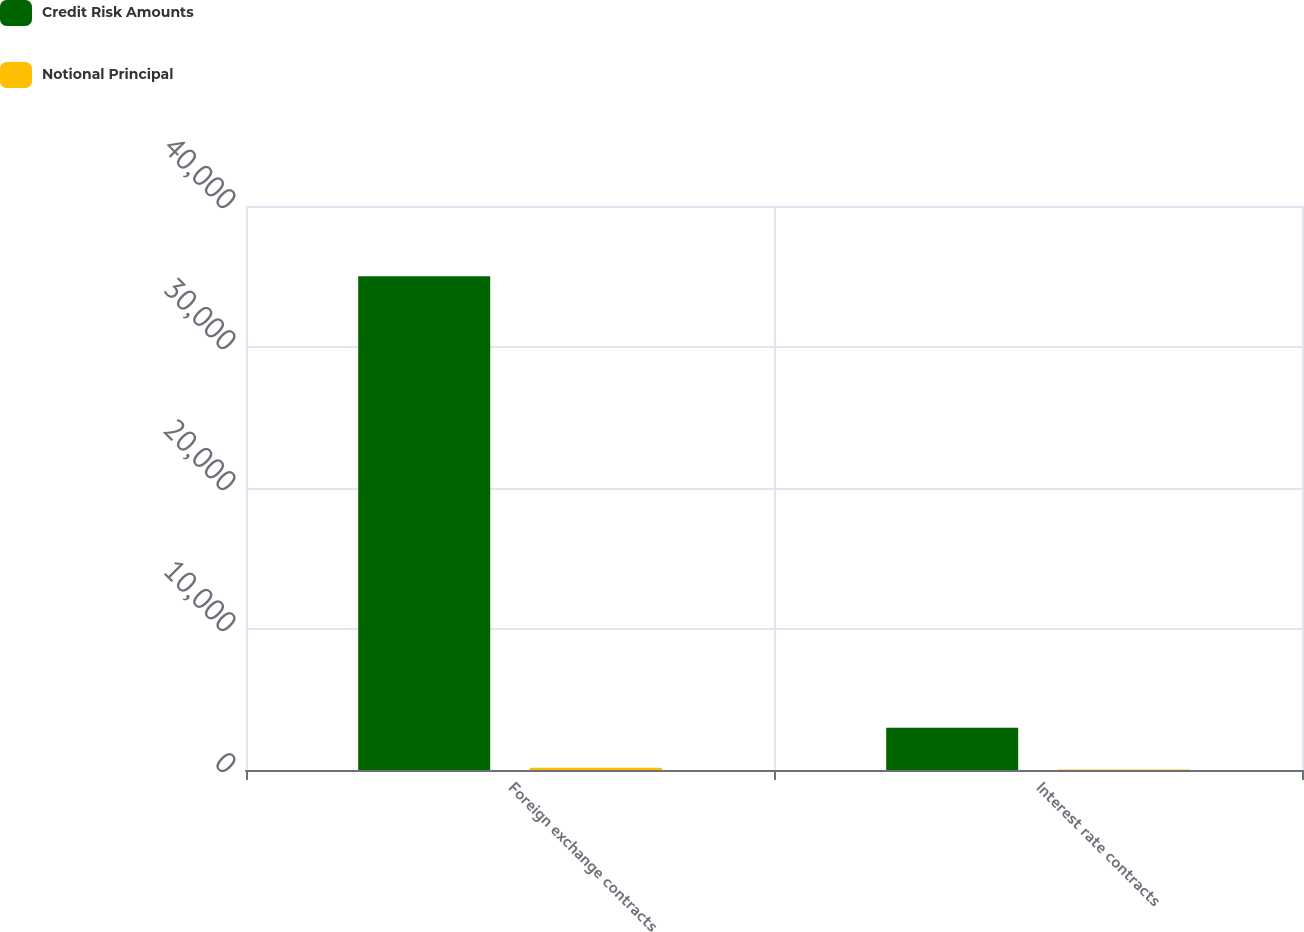Convert chart. <chart><loc_0><loc_0><loc_500><loc_500><stacked_bar_chart><ecel><fcel>Foreign exchange contracts<fcel>Interest rate contracts<nl><fcel>Credit Risk Amounts<fcel>35013<fcel>3000<nl><fcel>Notional Principal<fcel>159<fcel>44<nl></chart> 